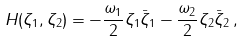<formula> <loc_0><loc_0><loc_500><loc_500>H ( \zeta _ { 1 } , \zeta _ { 2 } ) = - \frac { \omega _ { 1 } } { 2 } \zeta _ { 1 } \bar { \zeta } _ { 1 } - \frac { \omega _ { 2 } } { 2 } \zeta _ { 2 } \bar { \zeta } _ { 2 } \, ,</formula> 